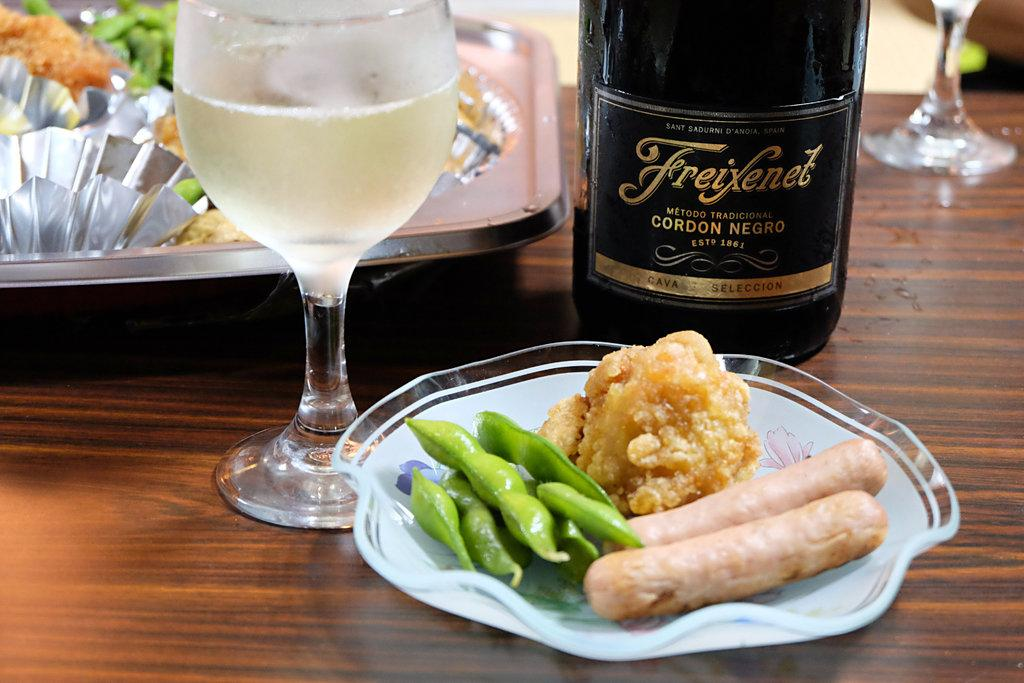<image>
Provide a brief description of the given image. A bottle of Freixenet Cordon Negro is next to a plate of food. 